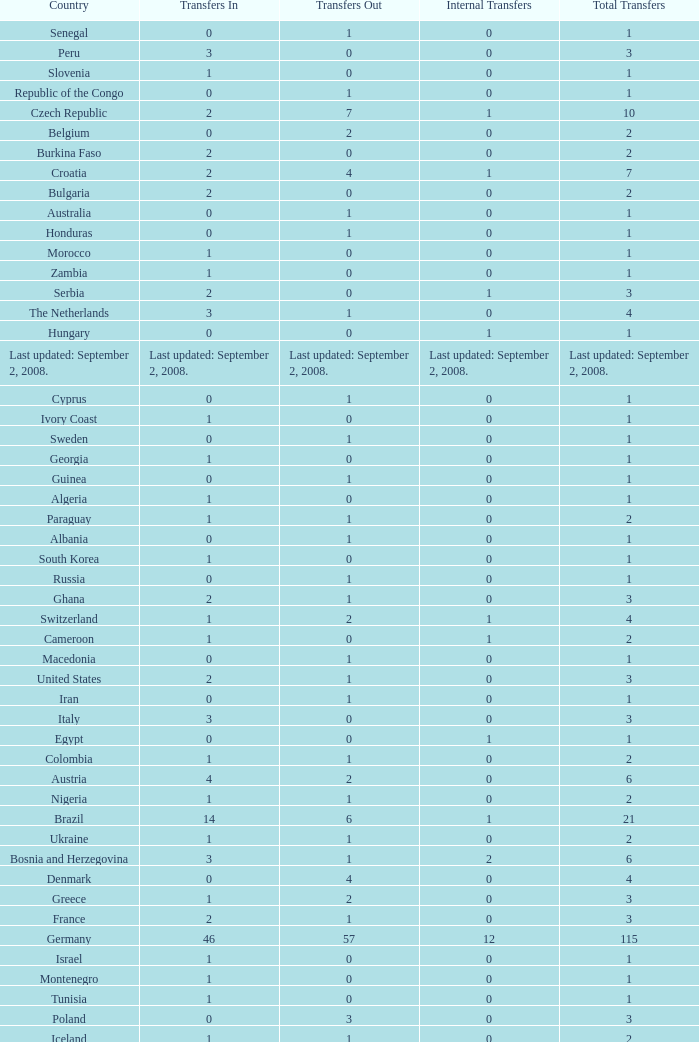What are the Transfers out for Peru? 0.0. 